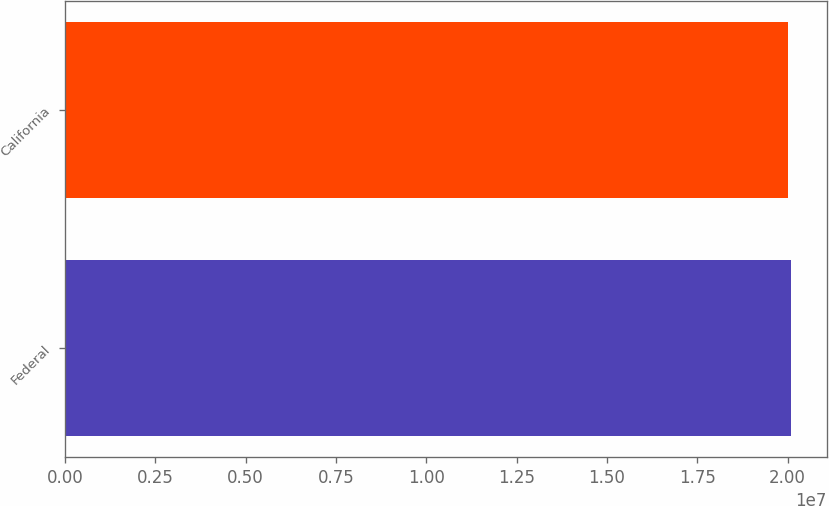<chart> <loc_0><loc_0><loc_500><loc_500><bar_chart><fcel>Federal<fcel>California<nl><fcel>2.0082e+07<fcel>2.0012e+07<nl></chart> 